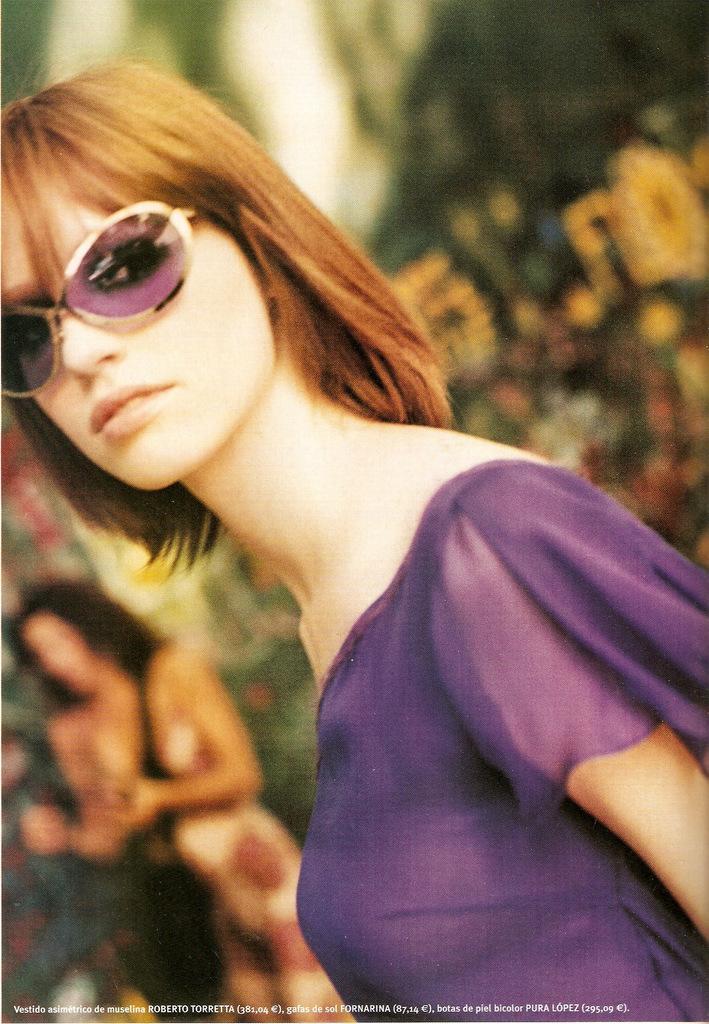In one or two sentences, can you explain what this image depicts? In this image, there is a person on the blur background. This person is wearing clothes and sunglasses. 